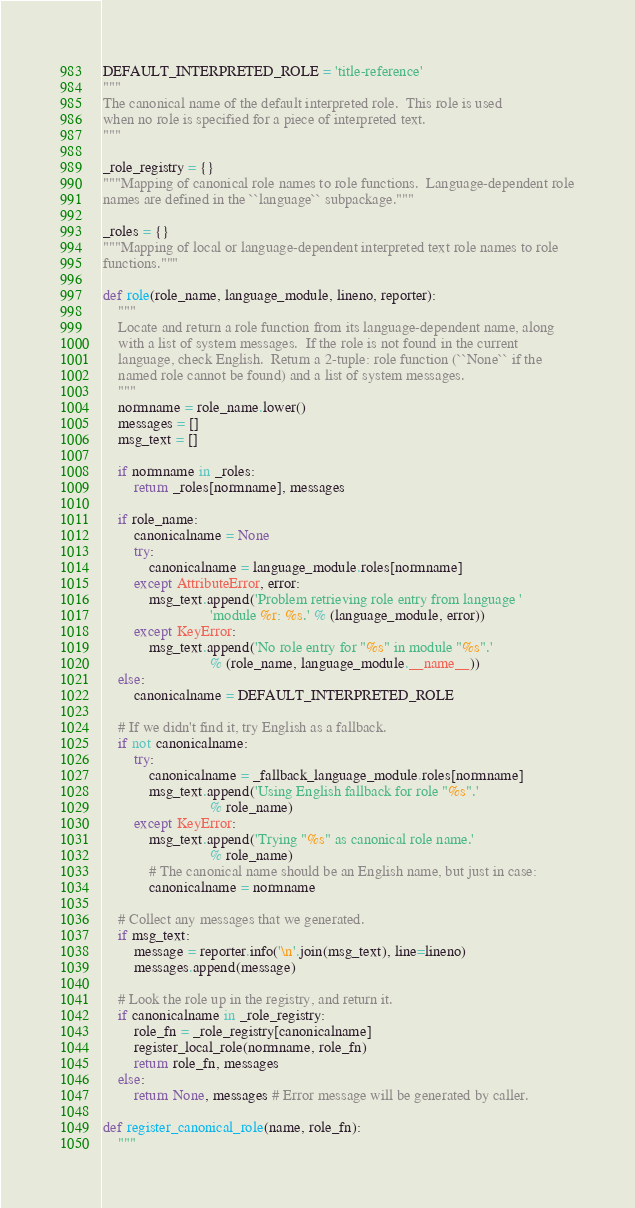<code> <loc_0><loc_0><loc_500><loc_500><_Python_>
DEFAULT_INTERPRETED_ROLE = 'title-reference'
"""
The canonical name of the default interpreted role.  This role is used
when no role is specified for a piece of interpreted text.
"""

_role_registry = {}
"""Mapping of canonical role names to role functions.  Language-dependent role
names are defined in the ``language`` subpackage."""

_roles = {}
"""Mapping of local or language-dependent interpreted text role names to role
functions."""

def role(role_name, language_module, lineno, reporter):
    """
    Locate and return a role function from its language-dependent name, along
    with a list of system messages.  If the role is not found in the current
    language, check English.  Return a 2-tuple: role function (``None`` if the
    named role cannot be found) and a list of system messages.
    """
    normname = role_name.lower()
    messages = []
    msg_text = []

    if normname in _roles:
        return _roles[normname], messages

    if role_name:
        canonicalname = None
        try:
            canonicalname = language_module.roles[normname]
        except AttributeError, error:
            msg_text.append('Problem retrieving role entry from language '
                            'module %r: %s.' % (language_module, error))
        except KeyError:
            msg_text.append('No role entry for "%s" in module "%s".'
                            % (role_name, language_module.__name__))
    else:
        canonicalname = DEFAULT_INTERPRETED_ROLE

    # If we didn't find it, try English as a fallback.
    if not canonicalname:
        try:
            canonicalname = _fallback_language_module.roles[normname]
            msg_text.append('Using English fallback for role "%s".'
                            % role_name)
        except KeyError:
            msg_text.append('Trying "%s" as canonical role name.'
                            % role_name)
            # The canonical name should be an English name, but just in case:
            canonicalname = normname

    # Collect any messages that we generated.
    if msg_text:
        message = reporter.info('\n'.join(msg_text), line=lineno)
        messages.append(message)

    # Look the role up in the registry, and return it.
    if canonicalname in _role_registry:
        role_fn = _role_registry[canonicalname]
        register_local_role(normname, role_fn)
        return role_fn, messages
    else:
        return None, messages # Error message will be generated by caller.

def register_canonical_role(name, role_fn):
    """</code> 